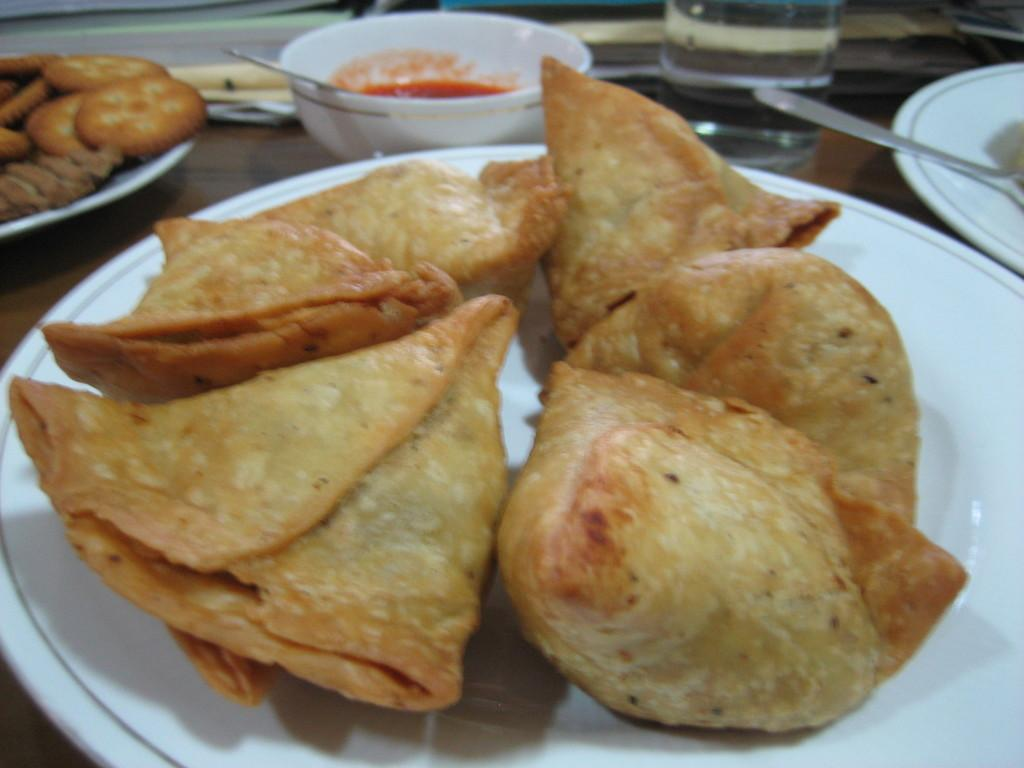What types of food can be seen in the image? There are food items in the plates and soup in a bowl. Can you describe the utensil used for the soup? There is a spoon in the soup bowl. Is there a utensil visible in the plate located in the top right of the image? Yes, there is a spoon in a plate in the top right of the image. What is the condition of the drain in the image? There is no drain present in the image. 